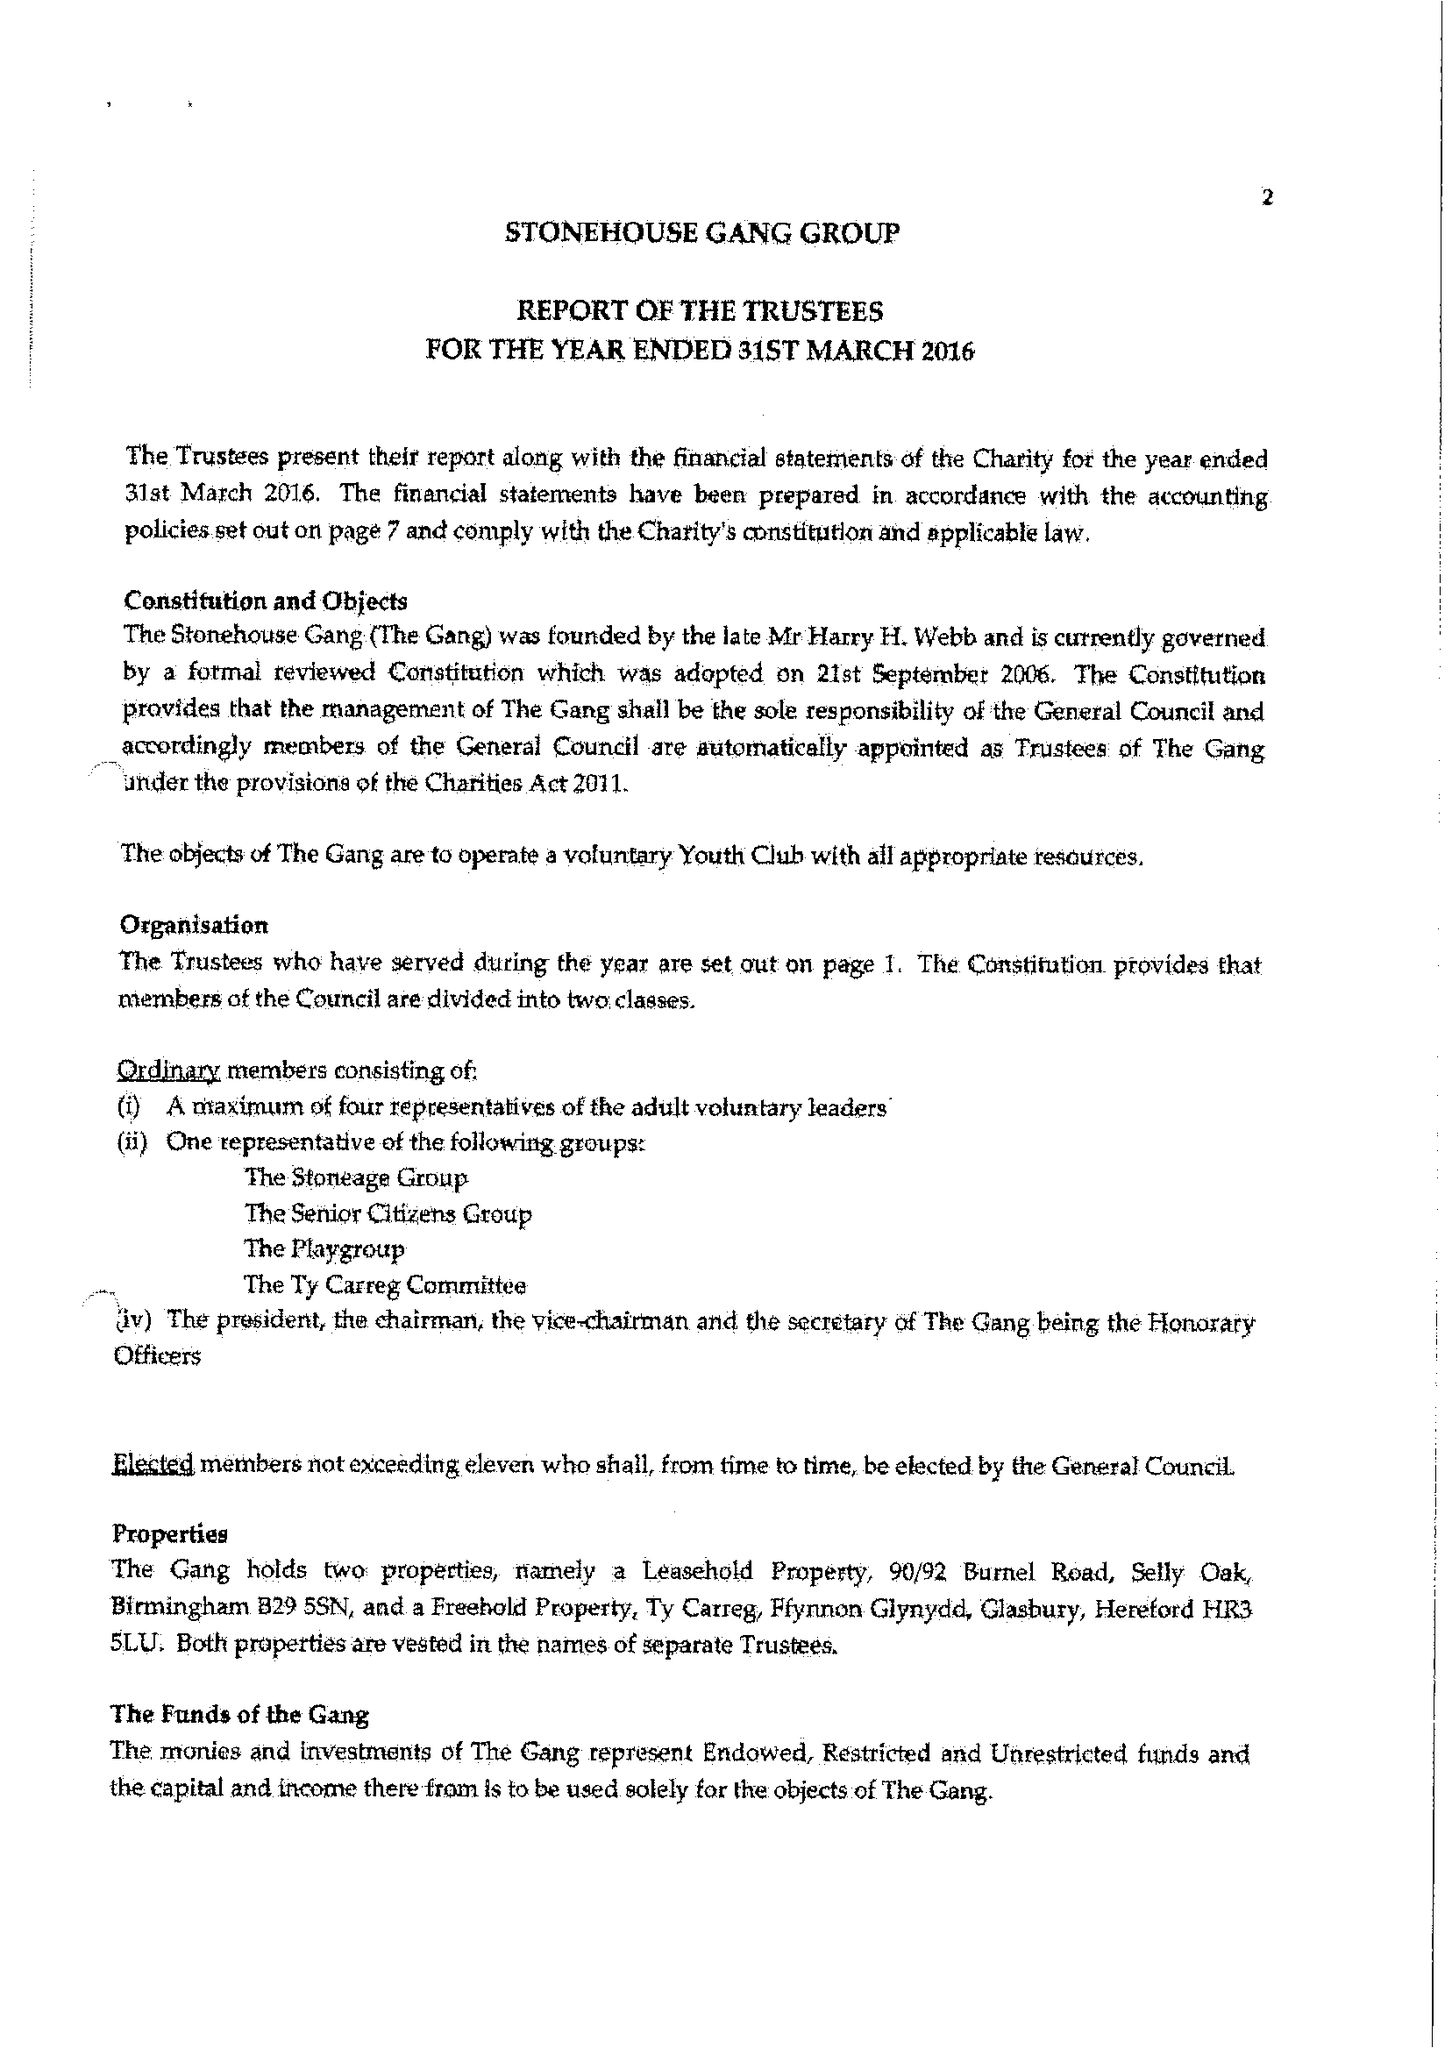What is the value for the charity_name?
Answer the question using a single word or phrase. Stonehouse Gang 